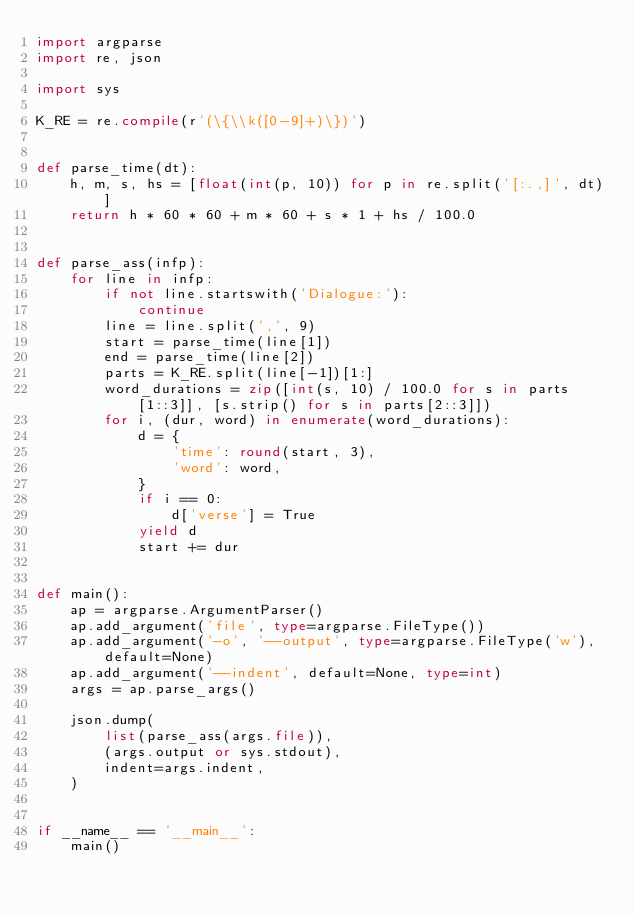<code> <loc_0><loc_0><loc_500><loc_500><_Python_>import argparse
import re, json

import sys

K_RE = re.compile(r'(\{\\k([0-9]+)\})')


def parse_time(dt):
    h, m, s, hs = [float(int(p, 10)) for p in re.split('[:.,]', dt)]
    return h * 60 * 60 + m * 60 + s * 1 + hs / 100.0


def parse_ass(infp):
    for line in infp:
        if not line.startswith('Dialogue:'):
            continue
        line = line.split(',', 9)
        start = parse_time(line[1])
        end = parse_time(line[2])
        parts = K_RE.split(line[-1])[1:]
        word_durations = zip([int(s, 10) / 100.0 for s in parts[1::3]], [s.strip() for s in parts[2::3]])
        for i, (dur, word) in enumerate(word_durations):
            d = {
                'time': round(start, 3),
                'word': word,
            }
            if i == 0:
                d['verse'] = True
            yield d
            start += dur


def main():
    ap = argparse.ArgumentParser()
    ap.add_argument('file', type=argparse.FileType())
    ap.add_argument('-o', '--output', type=argparse.FileType('w'), default=None)
    ap.add_argument('--indent', default=None, type=int)
    args = ap.parse_args()

    json.dump(
        list(parse_ass(args.file)),
        (args.output or sys.stdout),
        indent=args.indent,
    )


if __name__ == '__main__':
    main()
</code> 